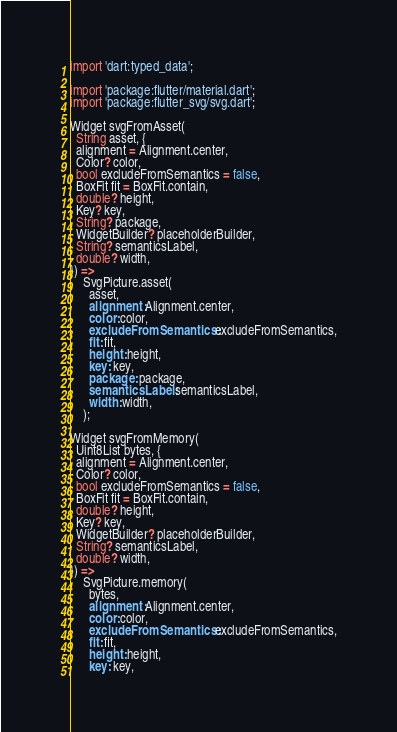<code> <loc_0><loc_0><loc_500><loc_500><_Dart_>import 'dart:typed_data';

import 'package:flutter/material.dart';
import 'package:flutter_svg/svg.dart';

Widget svgFromAsset(
  String asset, {
  alignment = Alignment.center,
  Color? color,
  bool excludeFromSemantics = false,
  BoxFit fit = BoxFit.contain,
  double? height,
  Key? key,
  String? package,
  WidgetBuilder? placeholderBuilder,
  String? semanticsLabel,
  double? width,
}) =>
    SvgPicture.asset(
      asset,
      alignment: Alignment.center,
      color: color,
      excludeFromSemantics: excludeFromSemantics,
      fit: fit,
      height: height,
      key: key,
      package: package,
      semanticsLabel: semanticsLabel,
      width: width,
    );

Widget svgFromMemory(
  Uint8List bytes, {
  alignment = Alignment.center,
  Color? color,
  bool excludeFromSemantics = false,
  BoxFit fit = BoxFit.contain,
  double? height,
  Key? key,
  WidgetBuilder? placeholderBuilder,
  String? semanticsLabel,
  double? width,
}) =>
    SvgPicture.memory(
      bytes,
      alignment: Alignment.center,
      color: color,
      excludeFromSemantics: excludeFromSemantics,
      fit: fit,
      height: height,
      key: key,</code> 